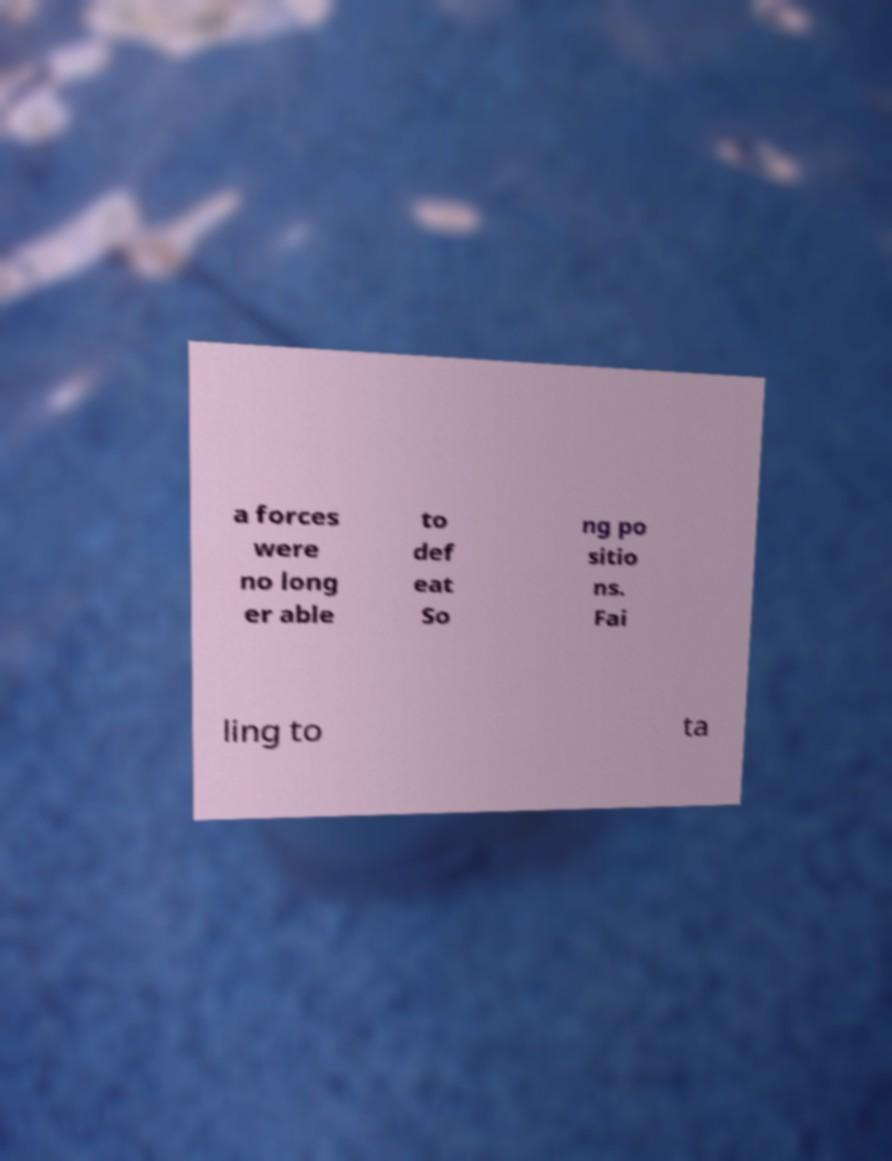Could you extract and type out the text from this image? a forces were no long er able to def eat So ng po sitio ns. Fai ling to ta 